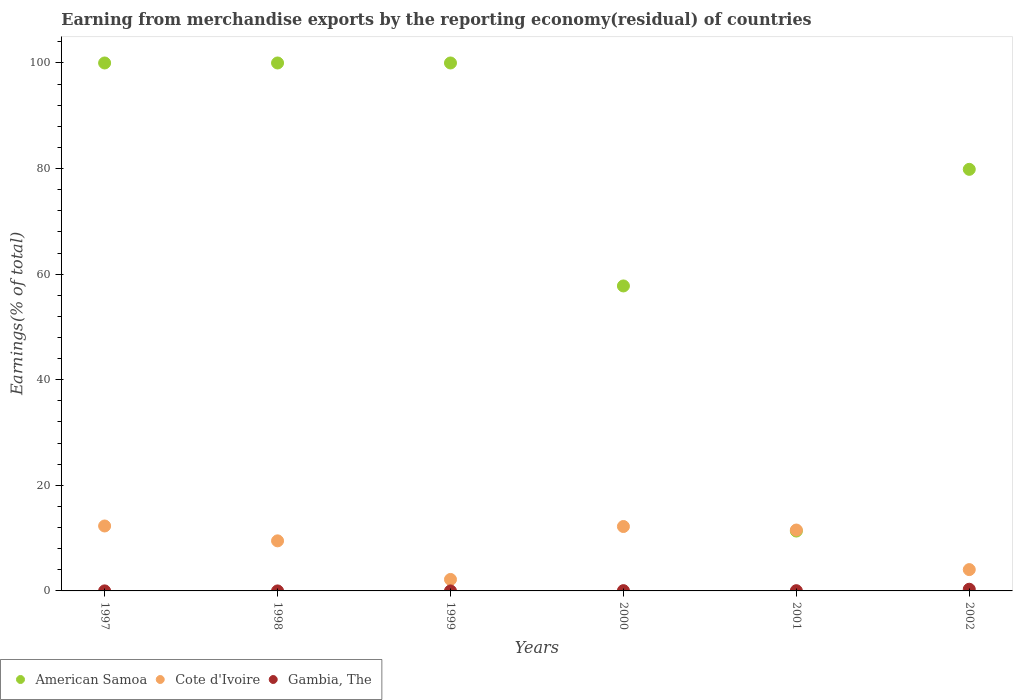What is the percentage of amount earned from merchandise exports in Cote d'Ivoire in 1999?
Your response must be concise. 2.17. Across all years, what is the maximum percentage of amount earned from merchandise exports in Gambia, The?
Ensure brevity in your answer.  0.32. Across all years, what is the minimum percentage of amount earned from merchandise exports in Cote d'Ivoire?
Your response must be concise. 2.17. What is the total percentage of amount earned from merchandise exports in American Samoa in the graph?
Your response must be concise. 448.96. What is the difference between the percentage of amount earned from merchandise exports in American Samoa in 2002 and the percentage of amount earned from merchandise exports in Gambia, The in 1999?
Give a very brief answer. 79.85. What is the average percentage of amount earned from merchandise exports in Cote d'Ivoire per year?
Offer a terse response. 8.62. In the year 2002, what is the difference between the percentage of amount earned from merchandise exports in Gambia, The and percentage of amount earned from merchandise exports in Cote d'Ivoire?
Keep it short and to the point. -3.72. What is the ratio of the percentage of amount earned from merchandise exports in Cote d'Ivoire in 2000 to that in 2002?
Your answer should be compact. 3.02. Is the difference between the percentage of amount earned from merchandise exports in Gambia, The in 1998 and 1999 greater than the difference between the percentage of amount earned from merchandise exports in Cote d'Ivoire in 1998 and 1999?
Your answer should be compact. No. What is the difference between the highest and the second highest percentage of amount earned from merchandise exports in Cote d'Ivoire?
Offer a very short reply. 0.1. What is the difference between the highest and the lowest percentage of amount earned from merchandise exports in American Samoa?
Provide a succinct answer. 88.66. In how many years, is the percentage of amount earned from merchandise exports in Gambia, The greater than the average percentage of amount earned from merchandise exports in Gambia, The taken over all years?
Keep it short and to the point. 1. Is the sum of the percentage of amount earned from merchandise exports in Cote d'Ivoire in 1998 and 2000 greater than the maximum percentage of amount earned from merchandise exports in Gambia, The across all years?
Provide a succinct answer. Yes. Is it the case that in every year, the sum of the percentage of amount earned from merchandise exports in Gambia, The and percentage of amount earned from merchandise exports in Cote d'Ivoire  is greater than the percentage of amount earned from merchandise exports in American Samoa?
Provide a short and direct response. No. Does the percentage of amount earned from merchandise exports in Cote d'Ivoire monotonically increase over the years?
Provide a succinct answer. No. Is the percentage of amount earned from merchandise exports in Gambia, The strictly greater than the percentage of amount earned from merchandise exports in American Samoa over the years?
Provide a short and direct response. No. Is the percentage of amount earned from merchandise exports in Gambia, The strictly less than the percentage of amount earned from merchandise exports in American Samoa over the years?
Ensure brevity in your answer.  Yes. How many dotlines are there?
Ensure brevity in your answer.  3. How many years are there in the graph?
Provide a short and direct response. 6. What is the difference between two consecutive major ticks on the Y-axis?
Your answer should be compact. 20. Does the graph contain any zero values?
Ensure brevity in your answer.  No. Does the graph contain grids?
Ensure brevity in your answer.  No. How are the legend labels stacked?
Provide a succinct answer. Horizontal. What is the title of the graph?
Your answer should be very brief. Earning from merchandise exports by the reporting economy(residual) of countries. Does "Congo (Republic)" appear as one of the legend labels in the graph?
Your response must be concise. No. What is the label or title of the X-axis?
Your answer should be compact. Years. What is the label or title of the Y-axis?
Your response must be concise. Earnings(% of total). What is the Earnings(% of total) in Cote d'Ivoire in 1997?
Keep it short and to the point. 12.3. What is the Earnings(% of total) of Gambia, The in 1997?
Provide a short and direct response. 0.01. What is the Earnings(% of total) of American Samoa in 1998?
Ensure brevity in your answer.  100. What is the Earnings(% of total) of Cote d'Ivoire in 1998?
Ensure brevity in your answer.  9.48. What is the Earnings(% of total) of Gambia, The in 1998?
Provide a short and direct response. 1.14900719103722e-8. What is the Earnings(% of total) of Cote d'Ivoire in 1999?
Your answer should be very brief. 2.17. What is the Earnings(% of total) of Gambia, The in 1999?
Give a very brief answer. 2.73727456770036e-9. What is the Earnings(% of total) in American Samoa in 2000?
Make the answer very short. 57.77. What is the Earnings(% of total) in Cote d'Ivoire in 2000?
Keep it short and to the point. 12.2. What is the Earnings(% of total) in Gambia, The in 2000?
Ensure brevity in your answer.  0.05. What is the Earnings(% of total) in American Samoa in 2001?
Provide a short and direct response. 11.34. What is the Earnings(% of total) in Cote d'Ivoire in 2001?
Make the answer very short. 11.53. What is the Earnings(% of total) in Gambia, The in 2001?
Your answer should be compact. 0.05. What is the Earnings(% of total) in American Samoa in 2002?
Your response must be concise. 79.85. What is the Earnings(% of total) of Cote d'Ivoire in 2002?
Offer a very short reply. 4.04. What is the Earnings(% of total) of Gambia, The in 2002?
Keep it short and to the point. 0.32. Across all years, what is the maximum Earnings(% of total) in American Samoa?
Provide a succinct answer. 100. Across all years, what is the maximum Earnings(% of total) in Cote d'Ivoire?
Make the answer very short. 12.3. Across all years, what is the maximum Earnings(% of total) of Gambia, The?
Ensure brevity in your answer.  0.32. Across all years, what is the minimum Earnings(% of total) in American Samoa?
Give a very brief answer. 11.34. Across all years, what is the minimum Earnings(% of total) of Cote d'Ivoire?
Offer a very short reply. 2.17. Across all years, what is the minimum Earnings(% of total) in Gambia, The?
Offer a terse response. 2.73727456770036e-9. What is the total Earnings(% of total) in American Samoa in the graph?
Keep it short and to the point. 448.96. What is the total Earnings(% of total) in Cote d'Ivoire in the graph?
Ensure brevity in your answer.  51.73. What is the total Earnings(% of total) of Gambia, The in the graph?
Your response must be concise. 0.42. What is the difference between the Earnings(% of total) in American Samoa in 1997 and that in 1998?
Make the answer very short. 0. What is the difference between the Earnings(% of total) in Cote d'Ivoire in 1997 and that in 1998?
Offer a terse response. 2.82. What is the difference between the Earnings(% of total) in Gambia, The in 1997 and that in 1998?
Your answer should be compact. 0.01. What is the difference between the Earnings(% of total) in Cote d'Ivoire in 1997 and that in 1999?
Your answer should be compact. 10.13. What is the difference between the Earnings(% of total) of Gambia, The in 1997 and that in 1999?
Your answer should be compact. 0.01. What is the difference between the Earnings(% of total) in American Samoa in 1997 and that in 2000?
Your answer should be compact. 42.23. What is the difference between the Earnings(% of total) in Cote d'Ivoire in 1997 and that in 2000?
Provide a succinct answer. 0.1. What is the difference between the Earnings(% of total) in Gambia, The in 1997 and that in 2000?
Make the answer very short. -0.04. What is the difference between the Earnings(% of total) in American Samoa in 1997 and that in 2001?
Your response must be concise. 88.66. What is the difference between the Earnings(% of total) in Cote d'Ivoire in 1997 and that in 2001?
Offer a terse response. 0.77. What is the difference between the Earnings(% of total) of Gambia, The in 1997 and that in 2001?
Provide a succinct answer. -0.04. What is the difference between the Earnings(% of total) of American Samoa in 1997 and that in 2002?
Your answer should be compact. 20.15. What is the difference between the Earnings(% of total) in Cote d'Ivoire in 1997 and that in 2002?
Ensure brevity in your answer.  8.26. What is the difference between the Earnings(% of total) of Gambia, The in 1997 and that in 2002?
Your response must be concise. -0.31. What is the difference between the Earnings(% of total) in Cote d'Ivoire in 1998 and that in 1999?
Provide a short and direct response. 7.31. What is the difference between the Earnings(% of total) in American Samoa in 1998 and that in 2000?
Your response must be concise. 42.23. What is the difference between the Earnings(% of total) of Cote d'Ivoire in 1998 and that in 2000?
Your response must be concise. -2.72. What is the difference between the Earnings(% of total) in Gambia, The in 1998 and that in 2000?
Provide a succinct answer. -0.05. What is the difference between the Earnings(% of total) of American Samoa in 1998 and that in 2001?
Give a very brief answer. 88.66. What is the difference between the Earnings(% of total) in Cote d'Ivoire in 1998 and that in 2001?
Offer a terse response. -2.05. What is the difference between the Earnings(% of total) of Gambia, The in 1998 and that in 2001?
Keep it short and to the point. -0.05. What is the difference between the Earnings(% of total) of American Samoa in 1998 and that in 2002?
Provide a succinct answer. 20.15. What is the difference between the Earnings(% of total) of Cote d'Ivoire in 1998 and that in 2002?
Keep it short and to the point. 5.45. What is the difference between the Earnings(% of total) of Gambia, The in 1998 and that in 2002?
Your answer should be very brief. -0.32. What is the difference between the Earnings(% of total) in American Samoa in 1999 and that in 2000?
Keep it short and to the point. 42.23. What is the difference between the Earnings(% of total) of Cote d'Ivoire in 1999 and that in 2000?
Keep it short and to the point. -10.03. What is the difference between the Earnings(% of total) in Gambia, The in 1999 and that in 2000?
Your answer should be very brief. -0.05. What is the difference between the Earnings(% of total) in American Samoa in 1999 and that in 2001?
Offer a very short reply. 88.66. What is the difference between the Earnings(% of total) in Cote d'Ivoire in 1999 and that in 2001?
Provide a succinct answer. -9.36. What is the difference between the Earnings(% of total) in Gambia, The in 1999 and that in 2001?
Offer a terse response. -0.05. What is the difference between the Earnings(% of total) in American Samoa in 1999 and that in 2002?
Offer a terse response. 20.15. What is the difference between the Earnings(% of total) in Cote d'Ivoire in 1999 and that in 2002?
Your answer should be compact. -1.86. What is the difference between the Earnings(% of total) in Gambia, The in 1999 and that in 2002?
Give a very brief answer. -0.32. What is the difference between the Earnings(% of total) in American Samoa in 2000 and that in 2001?
Your response must be concise. 46.43. What is the difference between the Earnings(% of total) of Cote d'Ivoire in 2000 and that in 2001?
Your answer should be compact. 0.67. What is the difference between the Earnings(% of total) in Gambia, The in 2000 and that in 2001?
Your answer should be compact. 0.01. What is the difference between the Earnings(% of total) in American Samoa in 2000 and that in 2002?
Offer a very short reply. -22.09. What is the difference between the Earnings(% of total) in Cote d'Ivoire in 2000 and that in 2002?
Your response must be concise. 8.16. What is the difference between the Earnings(% of total) of Gambia, The in 2000 and that in 2002?
Your answer should be very brief. -0.27. What is the difference between the Earnings(% of total) in American Samoa in 2001 and that in 2002?
Make the answer very short. -68.51. What is the difference between the Earnings(% of total) of Cote d'Ivoire in 2001 and that in 2002?
Provide a short and direct response. 7.49. What is the difference between the Earnings(% of total) in Gambia, The in 2001 and that in 2002?
Provide a succinct answer. -0.27. What is the difference between the Earnings(% of total) of American Samoa in 1997 and the Earnings(% of total) of Cote d'Ivoire in 1998?
Offer a very short reply. 90.52. What is the difference between the Earnings(% of total) in Cote d'Ivoire in 1997 and the Earnings(% of total) in Gambia, The in 1998?
Make the answer very short. 12.3. What is the difference between the Earnings(% of total) in American Samoa in 1997 and the Earnings(% of total) in Cote d'Ivoire in 1999?
Offer a terse response. 97.83. What is the difference between the Earnings(% of total) in American Samoa in 1997 and the Earnings(% of total) in Gambia, The in 1999?
Your answer should be very brief. 100. What is the difference between the Earnings(% of total) of Cote d'Ivoire in 1997 and the Earnings(% of total) of Gambia, The in 1999?
Your response must be concise. 12.3. What is the difference between the Earnings(% of total) of American Samoa in 1997 and the Earnings(% of total) of Cote d'Ivoire in 2000?
Offer a terse response. 87.8. What is the difference between the Earnings(% of total) in American Samoa in 1997 and the Earnings(% of total) in Gambia, The in 2000?
Your response must be concise. 99.95. What is the difference between the Earnings(% of total) in Cote d'Ivoire in 1997 and the Earnings(% of total) in Gambia, The in 2000?
Ensure brevity in your answer.  12.25. What is the difference between the Earnings(% of total) in American Samoa in 1997 and the Earnings(% of total) in Cote d'Ivoire in 2001?
Your answer should be compact. 88.47. What is the difference between the Earnings(% of total) of American Samoa in 1997 and the Earnings(% of total) of Gambia, The in 2001?
Offer a very short reply. 99.95. What is the difference between the Earnings(% of total) in Cote d'Ivoire in 1997 and the Earnings(% of total) in Gambia, The in 2001?
Offer a very short reply. 12.25. What is the difference between the Earnings(% of total) in American Samoa in 1997 and the Earnings(% of total) in Cote d'Ivoire in 2002?
Your answer should be very brief. 95.96. What is the difference between the Earnings(% of total) of American Samoa in 1997 and the Earnings(% of total) of Gambia, The in 2002?
Give a very brief answer. 99.68. What is the difference between the Earnings(% of total) of Cote d'Ivoire in 1997 and the Earnings(% of total) of Gambia, The in 2002?
Make the answer very short. 11.98. What is the difference between the Earnings(% of total) of American Samoa in 1998 and the Earnings(% of total) of Cote d'Ivoire in 1999?
Make the answer very short. 97.83. What is the difference between the Earnings(% of total) in American Samoa in 1998 and the Earnings(% of total) in Gambia, The in 1999?
Ensure brevity in your answer.  100. What is the difference between the Earnings(% of total) in Cote d'Ivoire in 1998 and the Earnings(% of total) in Gambia, The in 1999?
Offer a terse response. 9.48. What is the difference between the Earnings(% of total) in American Samoa in 1998 and the Earnings(% of total) in Cote d'Ivoire in 2000?
Your answer should be very brief. 87.8. What is the difference between the Earnings(% of total) in American Samoa in 1998 and the Earnings(% of total) in Gambia, The in 2000?
Offer a very short reply. 99.95. What is the difference between the Earnings(% of total) of Cote d'Ivoire in 1998 and the Earnings(% of total) of Gambia, The in 2000?
Your response must be concise. 9.43. What is the difference between the Earnings(% of total) in American Samoa in 1998 and the Earnings(% of total) in Cote d'Ivoire in 2001?
Ensure brevity in your answer.  88.47. What is the difference between the Earnings(% of total) of American Samoa in 1998 and the Earnings(% of total) of Gambia, The in 2001?
Offer a terse response. 99.95. What is the difference between the Earnings(% of total) in Cote d'Ivoire in 1998 and the Earnings(% of total) in Gambia, The in 2001?
Offer a very short reply. 9.44. What is the difference between the Earnings(% of total) in American Samoa in 1998 and the Earnings(% of total) in Cote d'Ivoire in 2002?
Give a very brief answer. 95.96. What is the difference between the Earnings(% of total) of American Samoa in 1998 and the Earnings(% of total) of Gambia, The in 2002?
Provide a short and direct response. 99.68. What is the difference between the Earnings(% of total) in Cote d'Ivoire in 1998 and the Earnings(% of total) in Gambia, The in 2002?
Your response must be concise. 9.17. What is the difference between the Earnings(% of total) of American Samoa in 1999 and the Earnings(% of total) of Cote d'Ivoire in 2000?
Give a very brief answer. 87.8. What is the difference between the Earnings(% of total) in American Samoa in 1999 and the Earnings(% of total) in Gambia, The in 2000?
Provide a short and direct response. 99.95. What is the difference between the Earnings(% of total) in Cote d'Ivoire in 1999 and the Earnings(% of total) in Gambia, The in 2000?
Make the answer very short. 2.12. What is the difference between the Earnings(% of total) in American Samoa in 1999 and the Earnings(% of total) in Cote d'Ivoire in 2001?
Keep it short and to the point. 88.47. What is the difference between the Earnings(% of total) in American Samoa in 1999 and the Earnings(% of total) in Gambia, The in 2001?
Your response must be concise. 99.95. What is the difference between the Earnings(% of total) of Cote d'Ivoire in 1999 and the Earnings(% of total) of Gambia, The in 2001?
Your answer should be very brief. 2.13. What is the difference between the Earnings(% of total) in American Samoa in 1999 and the Earnings(% of total) in Cote d'Ivoire in 2002?
Your response must be concise. 95.96. What is the difference between the Earnings(% of total) in American Samoa in 1999 and the Earnings(% of total) in Gambia, The in 2002?
Provide a short and direct response. 99.68. What is the difference between the Earnings(% of total) in Cote d'Ivoire in 1999 and the Earnings(% of total) in Gambia, The in 2002?
Provide a succinct answer. 1.86. What is the difference between the Earnings(% of total) in American Samoa in 2000 and the Earnings(% of total) in Cote d'Ivoire in 2001?
Your answer should be compact. 46.23. What is the difference between the Earnings(% of total) in American Samoa in 2000 and the Earnings(% of total) in Gambia, The in 2001?
Provide a short and direct response. 57.72. What is the difference between the Earnings(% of total) in Cote d'Ivoire in 2000 and the Earnings(% of total) in Gambia, The in 2001?
Your response must be concise. 12.15. What is the difference between the Earnings(% of total) of American Samoa in 2000 and the Earnings(% of total) of Cote d'Ivoire in 2002?
Provide a succinct answer. 53.73. What is the difference between the Earnings(% of total) of American Samoa in 2000 and the Earnings(% of total) of Gambia, The in 2002?
Your answer should be compact. 57.45. What is the difference between the Earnings(% of total) in Cote d'Ivoire in 2000 and the Earnings(% of total) in Gambia, The in 2002?
Keep it short and to the point. 11.88. What is the difference between the Earnings(% of total) of American Samoa in 2001 and the Earnings(% of total) of Cote d'Ivoire in 2002?
Ensure brevity in your answer.  7.3. What is the difference between the Earnings(% of total) of American Samoa in 2001 and the Earnings(% of total) of Gambia, The in 2002?
Your answer should be very brief. 11.02. What is the difference between the Earnings(% of total) of Cote d'Ivoire in 2001 and the Earnings(% of total) of Gambia, The in 2002?
Your answer should be compact. 11.21. What is the average Earnings(% of total) of American Samoa per year?
Ensure brevity in your answer.  74.83. What is the average Earnings(% of total) in Cote d'Ivoire per year?
Your answer should be very brief. 8.62. What is the average Earnings(% of total) in Gambia, The per year?
Provide a succinct answer. 0.07. In the year 1997, what is the difference between the Earnings(% of total) of American Samoa and Earnings(% of total) of Cote d'Ivoire?
Offer a terse response. 87.7. In the year 1997, what is the difference between the Earnings(% of total) in American Samoa and Earnings(% of total) in Gambia, The?
Provide a succinct answer. 99.99. In the year 1997, what is the difference between the Earnings(% of total) in Cote d'Ivoire and Earnings(% of total) in Gambia, The?
Offer a terse response. 12.29. In the year 1998, what is the difference between the Earnings(% of total) of American Samoa and Earnings(% of total) of Cote d'Ivoire?
Keep it short and to the point. 90.52. In the year 1998, what is the difference between the Earnings(% of total) in Cote d'Ivoire and Earnings(% of total) in Gambia, The?
Give a very brief answer. 9.48. In the year 1999, what is the difference between the Earnings(% of total) in American Samoa and Earnings(% of total) in Cote d'Ivoire?
Offer a very short reply. 97.83. In the year 1999, what is the difference between the Earnings(% of total) in Cote d'Ivoire and Earnings(% of total) in Gambia, The?
Offer a very short reply. 2.17. In the year 2000, what is the difference between the Earnings(% of total) in American Samoa and Earnings(% of total) in Cote d'Ivoire?
Keep it short and to the point. 45.57. In the year 2000, what is the difference between the Earnings(% of total) of American Samoa and Earnings(% of total) of Gambia, The?
Your response must be concise. 57.71. In the year 2000, what is the difference between the Earnings(% of total) of Cote d'Ivoire and Earnings(% of total) of Gambia, The?
Provide a succinct answer. 12.15. In the year 2001, what is the difference between the Earnings(% of total) of American Samoa and Earnings(% of total) of Cote d'Ivoire?
Give a very brief answer. -0.19. In the year 2001, what is the difference between the Earnings(% of total) of American Samoa and Earnings(% of total) of Gambia, The?
Provide a short and direct response. 11.3. In the year 2001, what is the difference between the Earnings(% of total) of Cote d'Ivoire and Earnings(% of total) of Gambia, The?
Your answer should be compact. 11.49. In the year 2002, what is the difference between the Earnings(% of total) in American Samoa and Earnings(% of total) in Cote d'Ivoire?
Provide a succinct answer. 75.81. In the year 2002, what is the difference between the Earnings(% of total) of American Samoa and Earnings(% of total) of Gambia, The?
Keep it short and to the point. 79.53. In the year 2002, what is the difference between the Earnings(% of total) of Cote d'Ivoire and Earnings(% of total) of Gambia, The?
Offer a terse response. 3.72. What is the ratio of the Earnings(% of total) of Cote d'Ivoire in 1997 to that in 1998?
Make the answer very short. 1.3. What is the ratio of the Earnings(% of total) of Gambia, The in 1997 to that in 1998?
Give a very brief answer. 5.81e+05. What is the ratio of the Earnings(% of total) of American Samoa in 1997 to that in 1999?
Provide a succinct answer. 1. What is the ratio of the Earnings(% of total) in Cote d'Ivoire in 1997 to that in 1999?
Provide a succinct answer. 5.66. What is the ratio of the Earnings(% of total) in Gambia, The in 1997 to that in 1999?
Offer a terse response. 2.44e+06. What is the ratio of the Earnings(% of total) of American Samoa in 1997 to that in 2000?
Your answer should be compact. 1.73. What is the ratio of the Earnings(% of total) in Cote d'Ivoire in 1997 to that in 2000?
Your answer should be compact. 1.01. What is the ratio of the Earnings(% of total) of Gambia, The in 1997 to that in 2000?
Provide a succinct answer. 0.13. What is the ratio of the Earnings(% of total) of American Samoa in 1997 to that in 2001?
Keep it short and to the point. 8.82. What is the ratio of the Earnings(% of total) in Cote d'Ivoire in 1997 to that in 2001?
Provide a succinct answer. 1.07. What is the ratio of the Earnings(% of total) of Gambia, The in 1997 to that in 2001?
Keep it short and to the point. 0.14. What is the ratio of the Earnings(% of total) of American Samoa in 1997 to that in 2002?
Your response must be concise. 1.25. What is the ratio of the Earnings(% of total) of Cote d'Ivoire in 1997 to that in 2002?
Ensure brevity in your answer.  3.05. What is the ratio of the Earnings(% of total) of Gambia, The in 1997 to that in 2002?
Your response must be concise. 0.02. What is the ratio of the Earnings(% of total) in American Samoa in 1998 to that in 1999?
Offer a very short reply. 1. What is the ratio of the Earnings(% of total) of Cote d'Ivoire in 1998 to that in 1999?
Make the answer very short. 4.36. What is the ratio of the Earnings(% of total) of Gambia, The in 1998 to that in 1999?
Ensure brevity in your answer.  4.2. What is the ratio of the Earnings(% of total) in American Samoa in 1998 to that in 2000?
Offer a very short reply. 1.73. What is the ratio of the Earnings(% of total) of Cote d'Ivoire in 1998 to that in 2000?
Give a very brief answer. 0.78. What is the ratio of the Earnings(% of total) in Gambia, The in 1998 to that in 2000?
Make the answer very short. 0. What is the ratio of the Earnings(% of total) in American Samoa in 1998 to that in 2001?
Your answer should be very brief. 8.82. What is the ratio of the Earnings(% of total) of Cote d'Ivoire in 1998 to that in 2001?
Provide a short and direct response. 0.82. What is the ratio of the Earnings(% of total) of American Samoa in 1998 to that in 2002?
Keep it short and to the point. 1.25. What is the ratio of the Earnings(% of total) of Cote d'Ivoire in 1998 to that in 2002?
Your answer should be very brief. 2.35. What is the ratio of the Earnings(% of total) in Gambia, The in 1998 to that in 2002?
Your response must be concise. 0. What is the ratio of the Earnings(% of total) in American Samoa in 1999 to that in 2000?
Make the answer very short. 1.73. What is the ratio of the Earnings(% of total) in Cote d'Ivoire in 1999 to that in 2000?
Your answer should be very brief. 0.18. What is the ratio of the Earnings(% of total) of Gambia, The in 1999 to that in 2000?
Keep it short and to the point. 0. What is the ratio of the Earnings(% of total) of American Samoa in 1999 to that in 2001?
Give a very brief answer. 8.82. What is the ratio of the Earnings(% of total) of Cote d'Ivoire in 1999 to that in 2001?
Your answer should be very brief. 0.19. What is the ratio of the Earnings(% of total) of Gambia, The in 1999 to that in 2001?
Offer a very short reply. 0. What is the ratio of the Earnings(% of total) in American Samoa in 1999 to that in 2002?
Offer a very short reply. 1.25. What is the ratio of the Earnings(% of total) in Cote d'Ivoire in 1999 to that in 2002?
Keep it short and to the point. 0.54. What is the ratio of the Earnings(% of total) in Gambia, The in 1999 to that in 2002?
Make the answer very short. 0. What is the ratio of the Earnings(% of total) of American Samoa in 2000 to that in 2001?
Your answer should be compact. 5.09. What is the ratio of the Earnings(% of total) in Cote d'Ivoire in 2000 to that in 2001?
Your response must be concise. 1.06. What is the ratio of the Earnings(% of total) of Gambia, The in 2000 to that in 2001?
Offer a terse response. 1.12. What is the ratio of the Earnings(% of total) in American Samoa in 2000 to that in 2002?
Keep it short and to the point. 0.72. What is the ratio of the Earnings(% of total) of Cote d'Ivoire in 2000 to that in 2002?
Provide a short and direct response. 3.02. What is the ratio of the Earnings(% of total) of Gambia, The in 2000 to that in 2002?
Ensure brevity in your answer.  0.16. What is the ratio of the Earnings(% of total) of American Samoa in 2001 to that in 2002?
Offer a very short reply. 0.14. What is the ratio of the Earnings(% of total) in Cote d'Ivoire in 2001 to that in 2002?
Provide a short and direct response. 2.86. What is the ratio of the Earnings(% of total) of Gambia, The in 2001 to that in 2002?
Your response must be concise. 0.15. What is the difference between the highest and the second highest Earnings(% of total) of American Samoa?
Keep it short and to the point. 0. What is the difference between the highest and the second highest Earnings(% of total) of Cote d'Ivoire?
Keep it short and to the point. 0.1. What is the difference between the highest and the second highest Earnings(% of total) in Gambia, The?
Keep it short and to the point. 0.27. What is the difference between the highest and the lowest Earnings(% of total) in American Samoa?
Provide a short and direct response. 88.66. What is the difference between the highest and the lowest Earnings(% of total) in Cote d'Ivoire?
Your answer should be compact. 10.13. What is the difference between the highest and the lowest Earnings(% of total) in Gambia, The?
Provide a succinct answer. 0.32. 